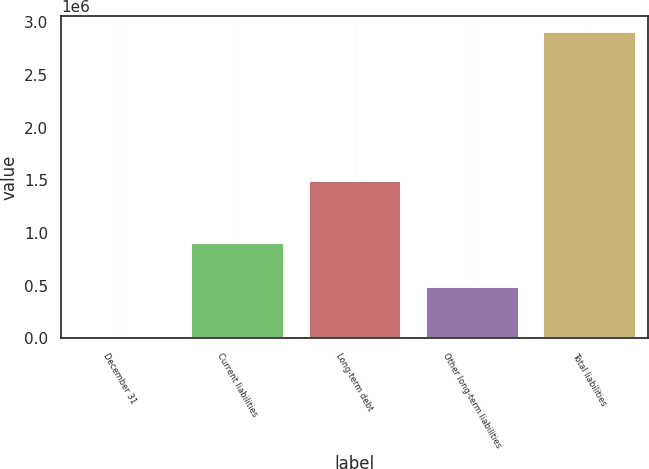Convert chart to OTSL. <chart><loc_0><loc_0><loc_500><loc_500><bar_chart><fcel>December 31<fcel>Current liabilities<fcel>Long-term debt<fcel>Other long-term liabilities<fcel>Total liabilities<nl><fcel>2009<fcel>910628<fcel>1.50273e+06<fcel>501334<fcel>2.91469e+06<nl></chart> 